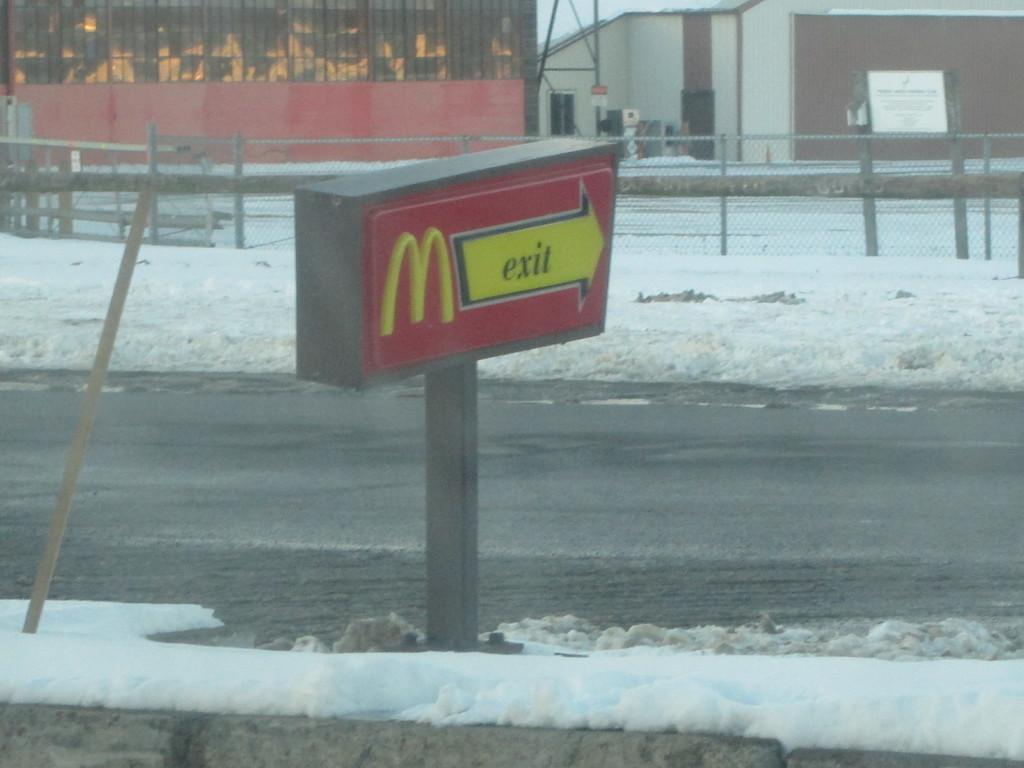Does it appear to be cold?
Give a very brief answer. Answering does not require reading text in the image. 